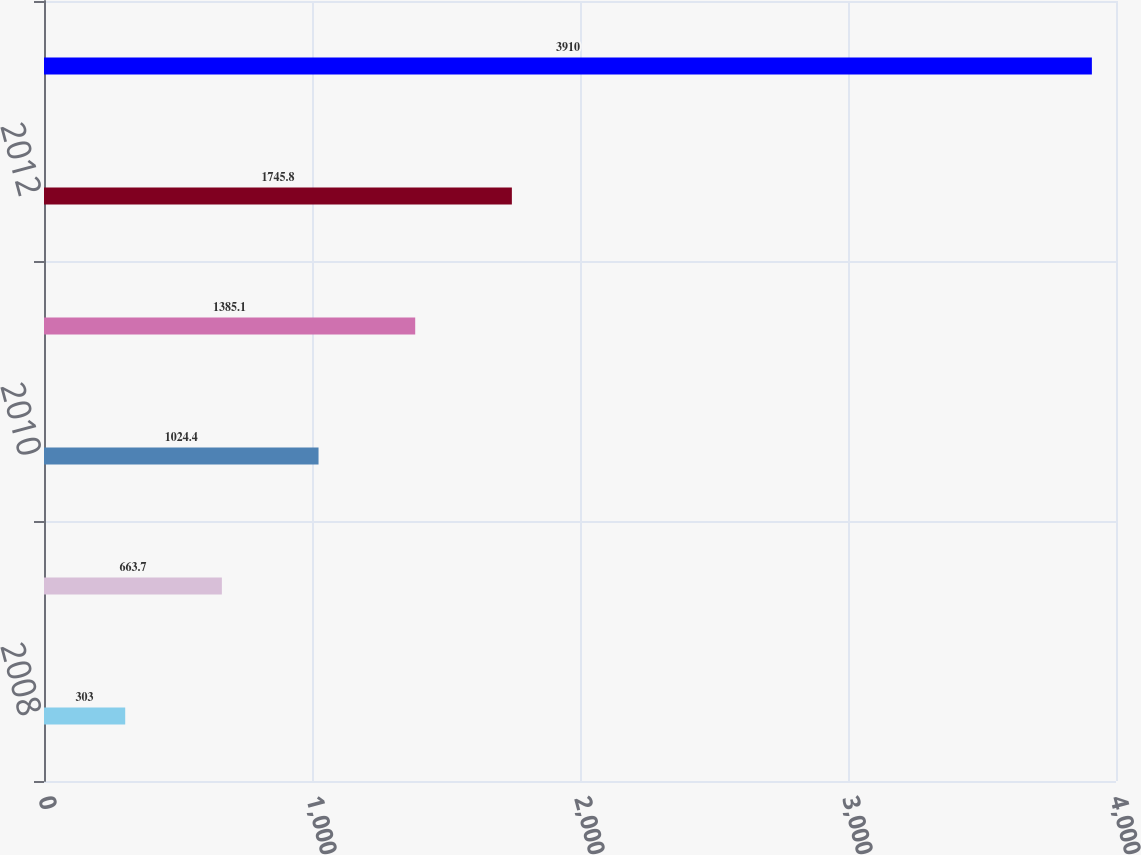Convert chart. <chart><loc_0><loc_0><loc_500><loc_500><bar_chart><fcel>2008<fcel>2009<fcel>2010<fcel>2011<fcel>2012<fcel>2013-2017<nl><fcel>303<fcel>663.7<fcel>1024.4<fcel>1385.1<fcel>1745.8<fcel>3910<nl></chart> 